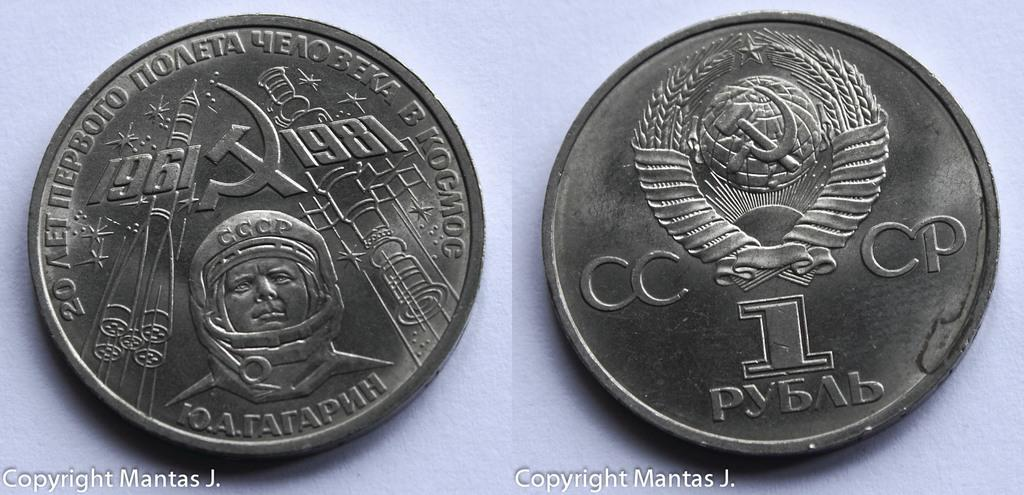<image>
Relay a brief, clear account of the picture shown. Two coins, one reading CCCP and the other 1961, 1981. 